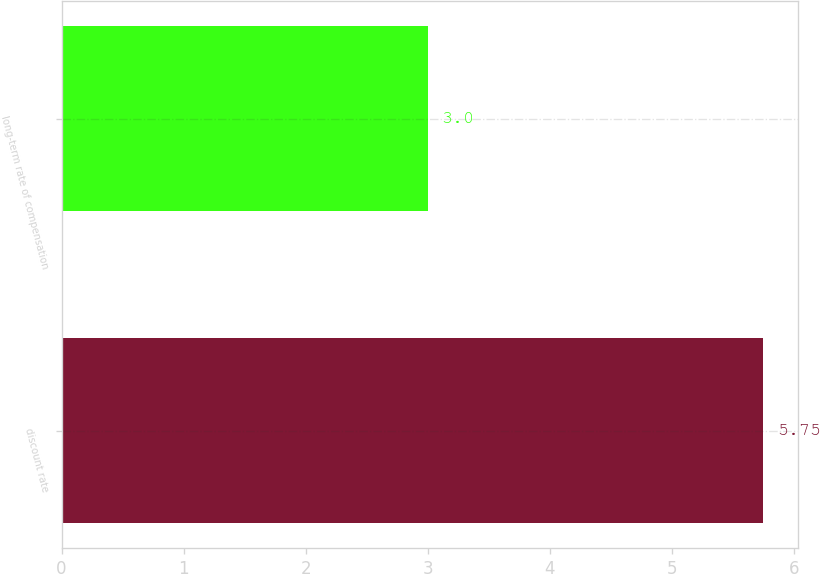<chart> <loc_0><loc_0><loc_500><loc_500><bar_chart><fcel>discount rate<fcel>long-term rate of compensation<nl><fcel>5.75<fcel>3<nl></chart> 